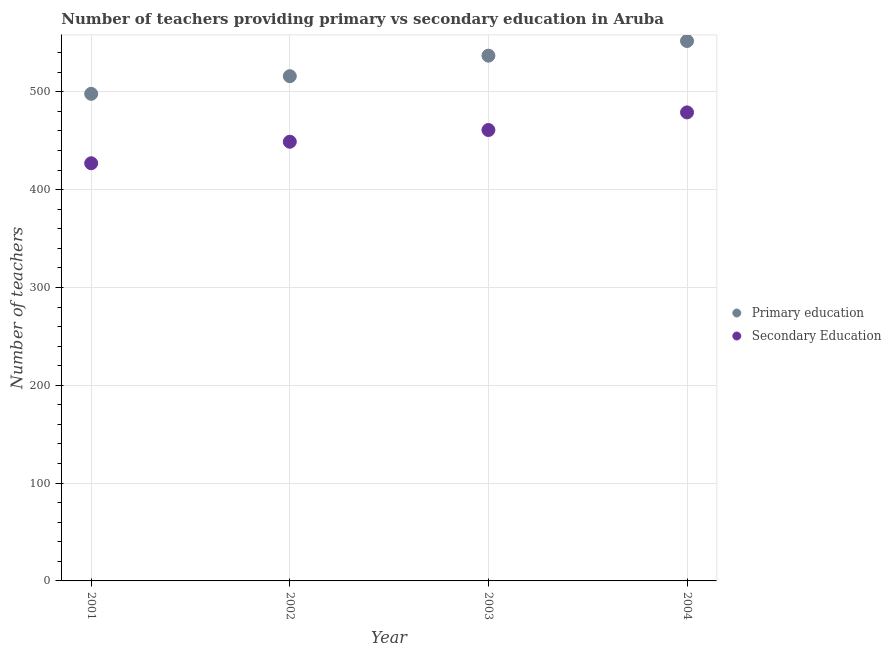How many different coloured dotlines are there?
Provide a short and direct response. 2. Is the number of dotlines equal to the number of legend labels?
Your answer should be compact. Yes. What is the number of secondary teachers in 2003?
Offer a terse response. 461. Across all years, what is the maximum number of primary teachers?
Your response must be concise. 552. Across all years, what is the minimum number of secondary teachers?
Give a very brief answer. 427. What is the total number of secondary teachers in the graph?
Give a very brief answer. 1816. What is the difference between the number of primary teachers in 2002 and that in 2003?
Provide a short and direct response. -21. What is the difference between the number of primary teachers in 2001 and the number of secondary teachers in 2004?
Provide a succinct answer. 19. What is the average number of primary teachers per year?
Offer a very short reply. 525.75. In the year 2004, what is the difference between the number of primary teachers and number of secondary teachers?
Keep it short and to the point. 73. In how many years, is the number of primary teachers greater than 20?
Your answer should be compact. 4. What is the ratio of the number of secondary teachers in 2001 to that in 2003?
Your answer should be very brief. 0.93. Is the number of primary teachers in 2002 less than that in 2004?
Provide a short and direct response. Yes. Is the difference between the number of primary teachers in 2001 and 2002 greater than the difference between the number of secondary teachers in 2001 and 2002?
Give a very brief answer. Yes. What is the difference between the highest and the lowest number of primary teachers?
Ensure brevity in your answer.  54. Is the sum of the number of secondary teachers in 2002 and 2004 greater than the maximum number of primary teachers across all years?
Provide a short and direct response. Yes. Is the number of secondary teachers strictly greater than the number of primary teachers over the years?
Provide a succinct answer. No. Is the number of secondary teachers strictly less than the number of primary teachers over the years?
Give a very brief answer. Yes. How many dotlines are there?
Provide a short and direct response. 2. How many years are there in the graph?
Offer a terse response. 4. What is the difference between two consecutive major ticks on the Y-axis?
Give a very brief answer. 100. Are the values on the major ticks of Y-axis written in scientific E-notation?
Provide a short and direct response. No. Does the graph contain grids?
Make the answer very short. Yes. Where does the legend appear in the graph?
Offer a very short reply. Center right. How many legend labels are there?
Ensure brevity in your answer.  2. How are the legend labels stacked?
Keep it short and to the point. Vertical. What is the title of the graph?
Provide a short and direct response. Number of teachers providing primary vs secondary education in Aruba. Does "Services" appear as one of the legend labels in the graph?
Make the answer very short. No. What is the label or title of the Y-axis?
Ensure brevity in your answer.  Number of teachers. What is the Number of teachers in Primary education in 2001?
Provide a short and direct response. 498. What is the Number of teachers of Secondary Education in 2001?
Provide a short and direct response. 427. What is the Number of teachers of Primary education in 2002?
Your answer should be very brief. 516. What is the Number of teachers of Secondary Education in 2002?
Offer a terse response. 449. What is the Number of teachers of Primary education in 2003?
Ensure brevity in your answer.  537. What is the Number of teachers of Secondary Education in 2003?
Give a very brief answer. 461. What is the Number of teachers of Primary education in 2004?
Keep it short and to the point. 552. What is the Number of teachers of Secondary Education in 2004?
Ensure brevity in your answer.  479. Across all years, what is the maximum Number of teachers of Primary education?
Offer a terse response. 552. Across all years, what is the maximum Number of teachers in Secondary Education?
Your response must be concise. 479. Across all years, what is the minimum Number of teachers in Primary education?
Your answer should be compact. 498. Across all years, what is the minimum Number of teachers of Secondary Education?
Provide a short and direct response. 427. What is the total Number of teachers of Primary education in the graph?
Provide a succinct answer. 2103. What is the total Number of teachers of Secondary Education in the graph?
Offer a very short reply. 1816. What is the difference between the Number of teachers in Primary education in 2001 and that in 2002?
Provide a short and direct response. -18. What is the difference between the Number of teachers of Secondary Education in 2001 and that in 2002?
Keep it short and to the point. -22. What is the difference between the Number of teachers in Primary education in 2001 and that in 2003?
Provide a succinct answer. -39. What is the difference between the Number of teachers of Secondary Education in 2001 and that in 2003?
Your response must be concise. -34. What is the difference between the Number of teachers of Primary education in 2001 and that in 2004?
Your response must be concise. -54. What is the difference between the Number of teachers of Secondary Education in 2001 and that in 2004?
Your answer should be very brief. -52. What is the difference between the Number of teachers in Primary education in 2002 and that in 2003?
Give a very brief answer. -21. What is the difference between the Number of teachers in Secondary Education in 2002 and that in 2003?
Offer a very short reply. -12. What is the difference between the Number of teachers in Primary education in 2002 and that in 2004?
Your response must be concise. -36. What is the difference between the Number of teachers of Secondary Education in 2002 and that in 2004?
Keep it short and to the point. -30. What is the difference between the Number of teachers of Primary education in 2001 and the Number of teachers of Secondary Education in 2002?
Make the answer very short. 49. What is the difference between the Number of teachers in Primary education in 2001 and the Number of teachers in Secondary Education in 2003?
Your answer should be compact. 37. What is the difference between the Number of teachers in Primary education in 2003 and the Number of teachers in Secondary Education in 2004?
Ensure brevity in your answer.  58. What is the average Number of teachers in Primary education per year?
Make the answer very short. 525.75. What is the average Number of teachers in Secondary Education per year?
Keep it short and to the point. 454. In the year 2001, what is the difference between the Number of teachers in Primary education and Number of teachers in Secondary Education?
Offer a terse response. 71. In the year 2002, what is the difference between the Number of teachers of Primary education and Number of teachers of Secondary Education?
Make the answer very short. 67. In the year 2004, what is the difference between the Number of teachers in Primary education and Number of teachers in Secondary Education?
Offer a very short reply. 73. What is the ratio of the Number of teachers in Primary education in 2001 to that in 2002?
Give a very brief answer. 0.97. What is the ratio of the Number of teachers of Secondary Education in 2001 to that in 2002?
Give a very brief answer. 0.95. What is the ratio of the Number of teachers in Primary education in 2001 to that in 2003?
Provide a succinct answer. 0.93. What is the ratio of the Number of teachers of Secondary Education in 2001 to that in 2003?
Ensure brevity in your answer.  0.93. What is the ratio of the Number of teachers of Primary education in 2001 to that in 2004?
Make the answer very short. 0.9. What is the ratio of the Number of teachers of Secondary Education in 2001 to that in 2004?
Your answer should be compact. 0.89. What is the ratio of the Number of teachers in Primary education in 2002 to that in 2003?
Provide a short and direct response. 0.96. What is the ratio of the Number of teachers in Primary education in 2002 to that in 2004?
Keep it short and to the point. 0.93. What is the ratio of the Number of teachers in Secondary Education in 2002 to that in 2004?
Your answer should be compact. 0.94. What is the ratio of the Number of teachers of Primary education in 2003 to that in 2004?
Provide a short and direct response. 0.97. What is the ratio of the Number of teachers of Secondary Education in 2003 to that in 2004?
Your answer should be compact. 0.96. What is the difference between the highest and the lowest Number of teachers of Primary education?
Provide a succinct answer. 54. 